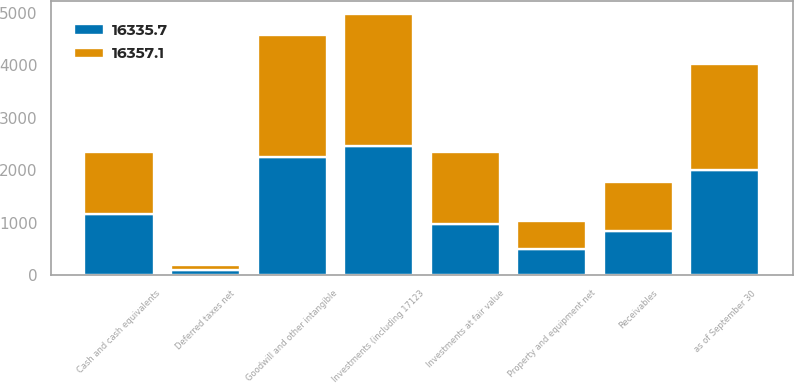Convert chart. <chart><loc_0><loc_0><loc_500><loc_500><stacked_bar_chart><ecel><fcel>as of September 30<fcel>Cash and cash equivalents<fcel>Receivables<fcel>Investments (including 17123<fcel>Investments at fair value<fcel>Deferred taxes net<fcel>Property and equipment net<fcel>Goodwill and other intangible<nl><fcel>16335.7<fcel>2015<fcel>1175.55<fcel>838<fcel>2459.2<fcel>977.4<fcel>100.7<fcel>510.1<fcel>2257<nl><fcel>16357.1<fcel>2014<fcel>1175.55<fcel>950<fcel>2516.1<fcel>1373.7<fcel>98.1<fcel>530.7<fcel>2325.9<nl></chart> 